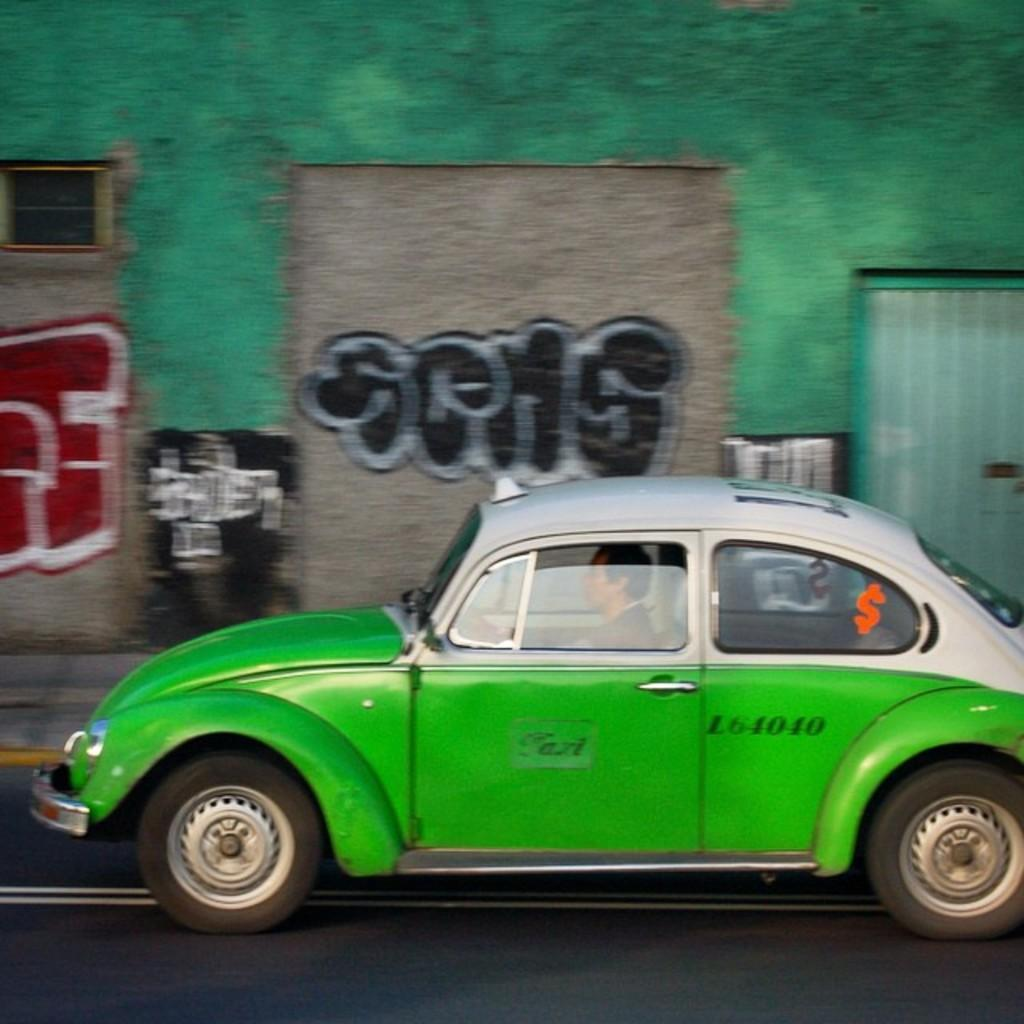What type of vehicle is in the image? There is a green car in the image. What is the car doing in the image? The car is moving on the road. Is there anyone inside the car? Yes, there is a person sitting in the car. What can be seen in the background of the image? There is a green color wall in the background of the image. What time of day is it in the image, and is the person in the car taking a test? The time of day is not mentioned in the image, and there is no indication that the person in the car is taking a test. 